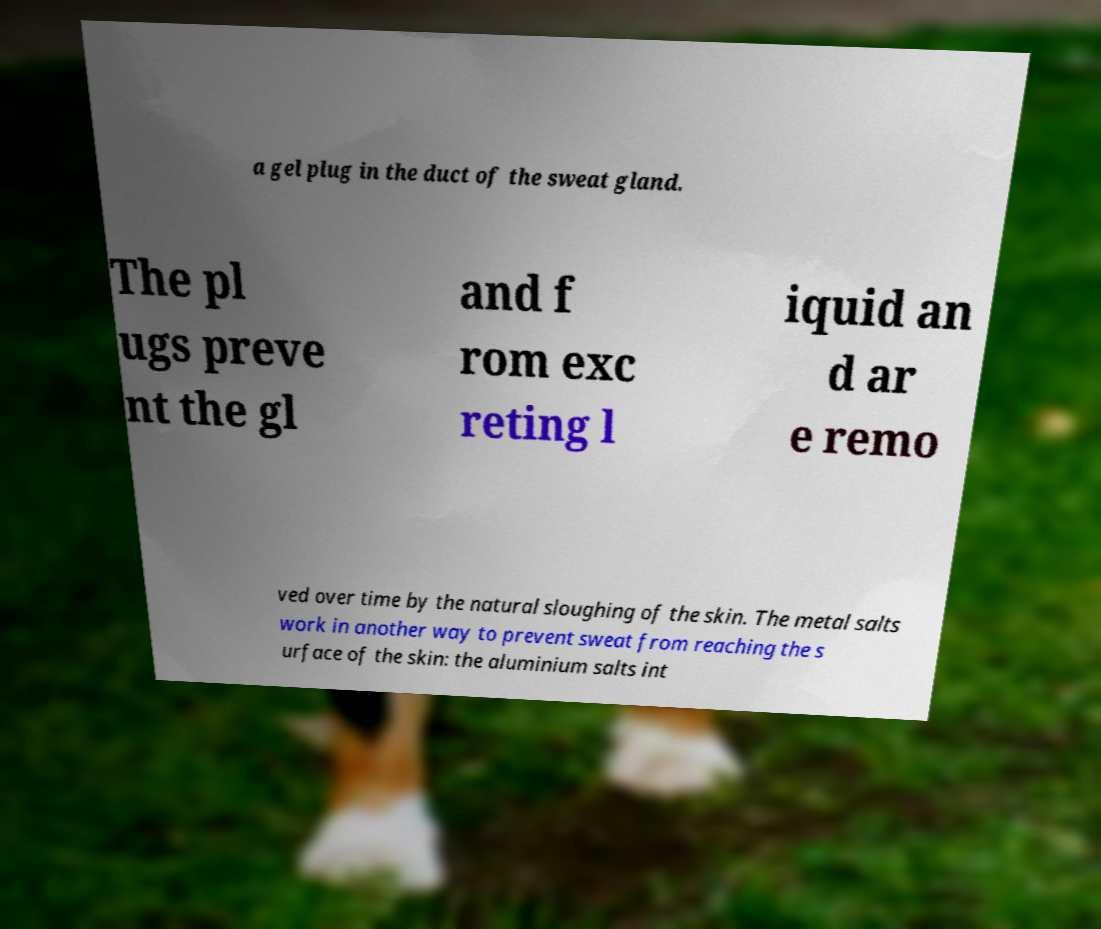Please read and relay the text visible in this image. What does it say? a gel plug in the duct of the sweat gland. The pl ugs preve nt the gl and f rom exc reting l iquid an d ar e remo ved over time by the natural sloughing of the skin. The metal salts work in another way to prevent sweat from reaching the s urface of the skin: the aluminium salts int 